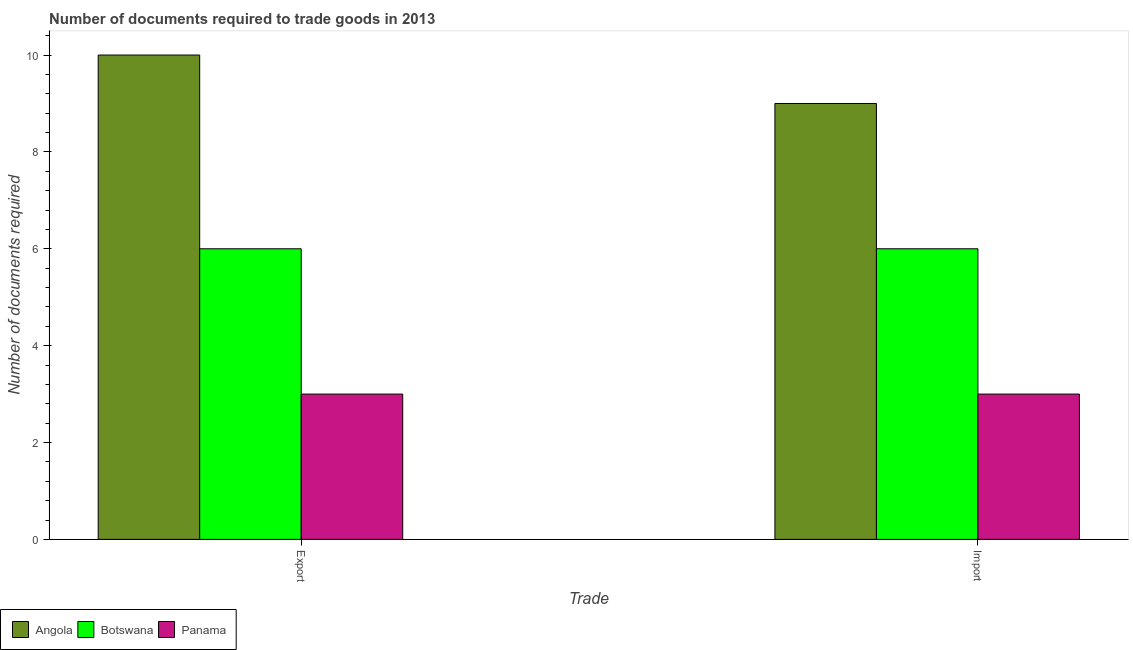How many different coloured bars are there?
Give a very brief answer. 3. Are the number of bars per tick equal to the number of legend labels?
Your answer should be very brief. Yes. How many bars are there on the 1st tick from the right?
Keep it short and to the point. 3. What is the label of the 2nd group of bars from the left?
Give a very brief answer. Import. What is the number of documents required to export goods in Panama?
Offer a very short reply. 3. Across all countries, what is the maximum number of documents required to export goods?
Provide a short and direct response. 10. Across all countries, what is the minimum number of documents required to export goods?
Your response must be concise. 3. In which country was the number of documents required to export goods maximum?
Give a very brief answer. Angola. In which country was the number of documents required to export goods minimum?
Your response must be concise. Panama. What is the total number of documents required to export goods in the graph?
Make the answer very short. 19. What is the difference between the number of documents required to import goods in Botswana and that in Angola?
Offer a very short reply. -3. What is the difference between the number of documents required to export goods in Angola and the number of documents required to import goods in Botswana?
Offer a very short reply. 4. In how many countries, is the number of documents required to export goods greater than 5.6 ?
Your answer should be compact. 2. What does the 3rd bar from the left in Import represents?
Make the answer very short. Panama. What does the 2nd bar from the right in Export represents?
Offer a very short reply. Botswana. How many bars are there?
Your answer should be compact. 6. Are all the bars in the graph horizontal?
Your response must be concise. No. What is the difference between two consecutive major ticks on the Y-axis?
Your response must be concise. 2. Are the values on the major ticks of Y-axis written in scientific E-notation?
Offer a very short reply. No. Does the graph contain any zero values?
Your answer should be very brief. No. Does the graph contain grids?
Your answer should be very brief. No. How many legend labels are there?
Keep it short and to the point. 3. What is the title of the graph?
Ensure brevity in your answer.  Number of documents required to trade goods in 2013. What is the label or title of the X-axis?
Offer a very short reply. Trade. What is the label or title of the Y-axis?
Provide a succinct answer. Number of documents required. What is the Number of documents required in Angola in Export?
Ensure brevity in your answer.  10. What is the Number of documents required of Botswana in Export?
Your answer should be very brief. 6. What is the Number of documents required of Panama in Export?
Make the answer very short. 3. Across all Trade, what is the maximum Number of documents required of Panama?
Your answer should be compact. 3. Across all Trade, what is the minimum Number of documents required of Angola?
Offer a terse response. 9. Across all Trade, what is the minimum Number of documents required in Botswana?
Provide a short and direct response. 6. What is the total Number of documents required of Angola in the graph?
Keep it short and to the point. 19. What is the total Number of documents required of Botswana in the graph?
Your answer should be very brief. 12. What is the total Number of documents required of Panama in the graph?
Offer a terse response. 6. What is the difference between the Number of documents required of Angola in Export and the Number of documents required of Botswana in Import?
Give a very brief answer. 4. What is the average Number of documents required in Botswana per Trade?
Provide a short and direct response. 6. What is the difference between the Number of documents required in Angola and Number of documents required in Botswana in Export?
Offer a very short reply. 4. What is the difference between the Number of documents required of Angola and Number of documents required of Botswana in Import?
Make the answer very short. 3. What is the difference between the Number of documents required of Botswana and Number of documents required of Panama in Import?
Make the answer very short. 3. What is the ratio of the Number of documents required in Botswana in Export to that in Import?
Your response must be concise. 1. What is the ratio of the Number of documents required in Panama in Export to that in Import?
Your answer should be very brief. 1. What is the difference between the highest and the second highest Number of documents required of Angola?
Your answer should be compact. 1. What is the difference between the highest and the lowest Number of documents required of Botswana?
Offer a terse response. 0. What is the difference between the highest and the lowest Number of documents required in Panama?
Your response must be concise. 0. 